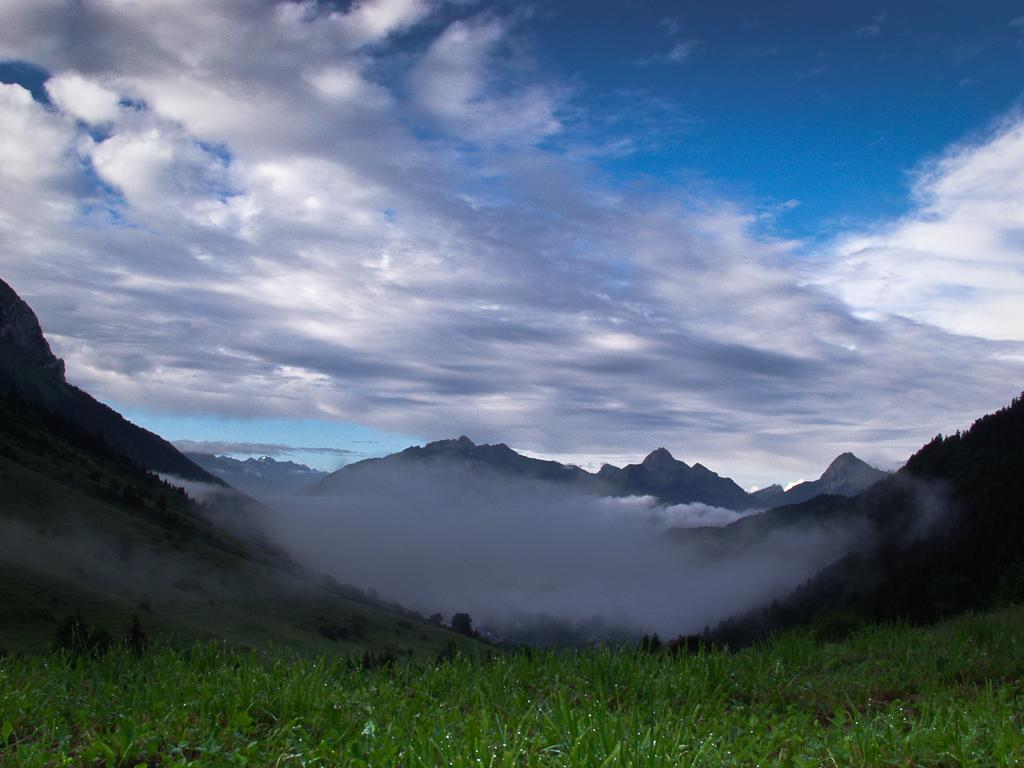What is visible in the background of the image? The sky is visible in the image. What can be seen in the sky in the image? There are clouds in the sky. What type of natural landform is present in the image? There are hills in the image. What type of vegetation is present on the ground in the image? There is grass on the ground in the image. Can you see a crow perched on the part of the bed in the image? There is no crow or bed present in the image. 